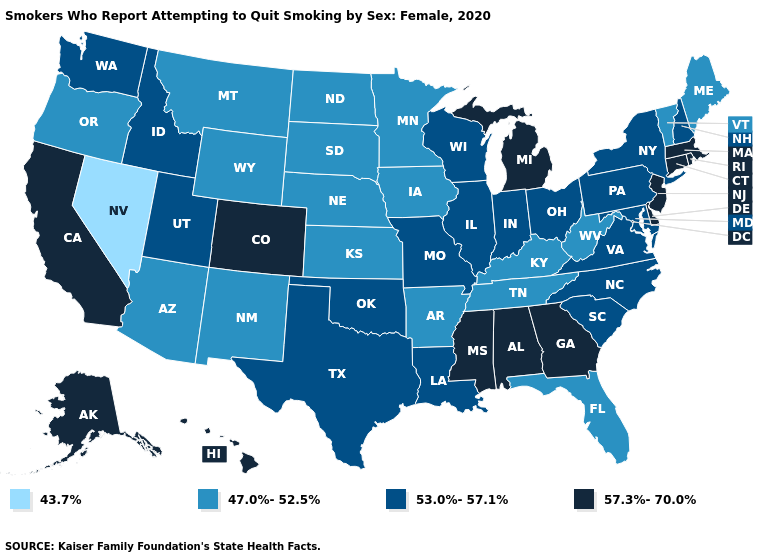Among the states that border Arkansas , does Mississippi have the highest value?
Keep it brief. Yes. Which states have the lowest value in the MidWest?
Give a very brief answer. Iowa, Kansas, Minnesota, Nebraska, North Dakota, South Dakota. Does Kansas have the same value as Oregon?
Concise answer only. Yes. What is the lowest value in states that border West Virginia?
Short answer required. 47.0%-52.5%. Which states have the lowest value in the Northeast?
Be succinct. Maine, Vermont. What is the highest value in the West ?
Be succinct. 57.3%-70.0%. What is the value of Delaware?
Concise answer only. 57.3%-70.0%. Name the states that have a value in the range 53.0%-57.1%?
Write a very short answer. Idaho, Illinois, Indiana, Louisiana, Maryland, Missouri, New Hampshire, New York, North Carolina, Ohio, Oklahoma, Pennsylvania, South Carolina, Texas, Utah, Virginia, Washington, Wisconsin. Does Montana have the lowest value in the USA?
Answer briefly. No. Among the states that border Virginia , which have the lowest value?
Short answer required. Kentucky, Tennessee, West Virginia. Name the states that have a value in the range 43.7%?
Write a very short answer. Nevada. Does Kansas have a higher value than Nevada?
Be succinct. Yes. Does Utah have a lower value than Oregon?
Give a very brief answer. No. Which states have the highest value in the USA?
Concise answer only. Alabama, Alaska, California, Colorado, Connecticut, Delaware, Georgia, Hawaii, Massachusetts, Michigan, Mississippi, New Jersey, Rhode Island. What is the value of Maryland?
Write a very short answer. 53.0%-57.1%. 